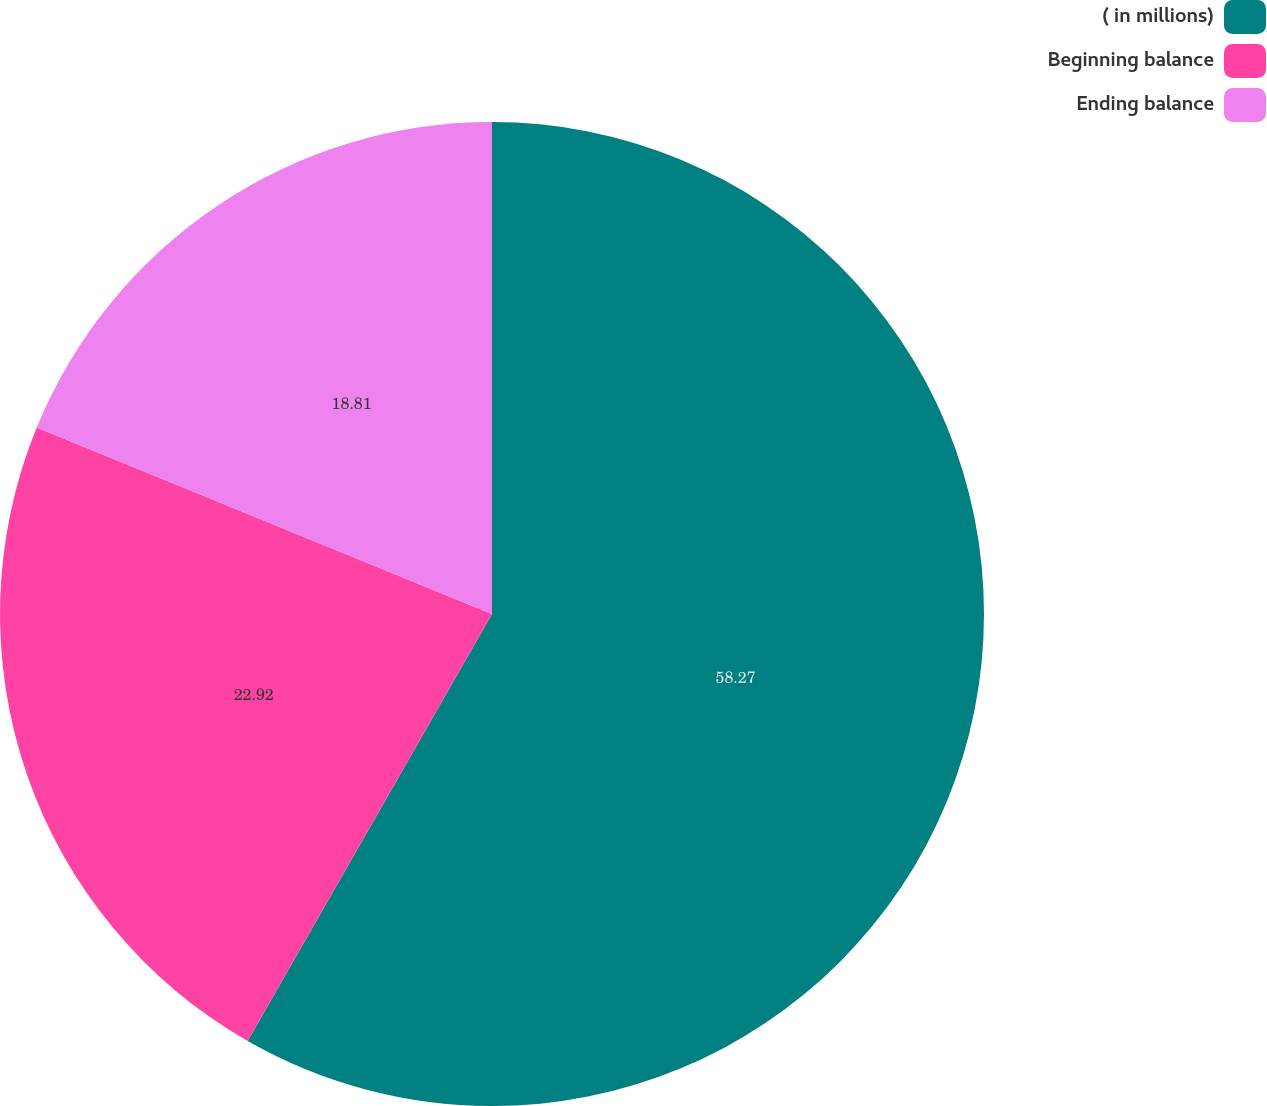Convert chart to OTSL. <chart><loc_0><loc_0><loc_500><loc_500><pie_chart><fcel>( in millions)<fcel>Beginning balance<fcel>Ending balance<nl><fcel>58.27%<fcel>22.92%<fcel>18.81%<nl></chart> 